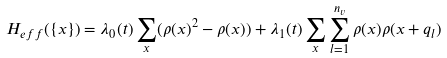Convert formula to latex. <formula><loc_0><loc_0><loc_500><loc_500>H _ { e f f } ( \{ { x } \} ) = \lambda _ { 0 } ( t ) \sum _ { x } ( \rho ( { x } ) ^ { 2 } - \rho ( { x } ) ) + \lambda _ { 1 } ( t ) \sum _ { x } \sum _ { l = 1 } ^ { n _ { v } } \rho ( { x } ) \rho ( { x } + { q _ { l } } )</formula> 